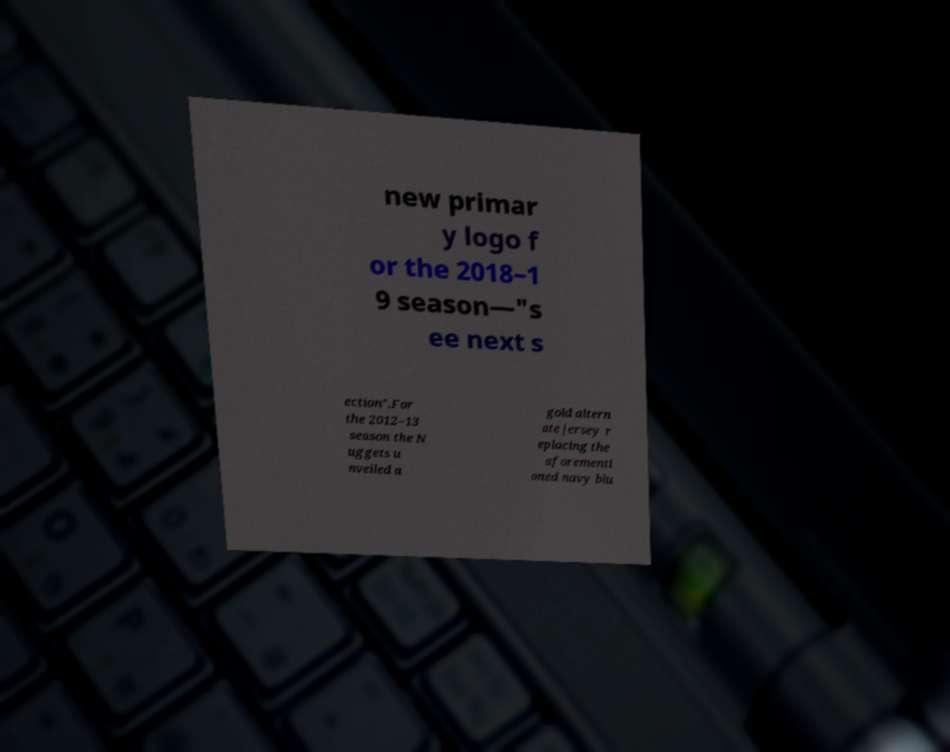Could you extract and type out the text from this image? new primar y logo f or the 2018–1 9 season—"s ee next s ection".For the 2012–13 season the N uggets u nveiled a gold altern ate jersey r eplacing the aforementi oned navy blu 